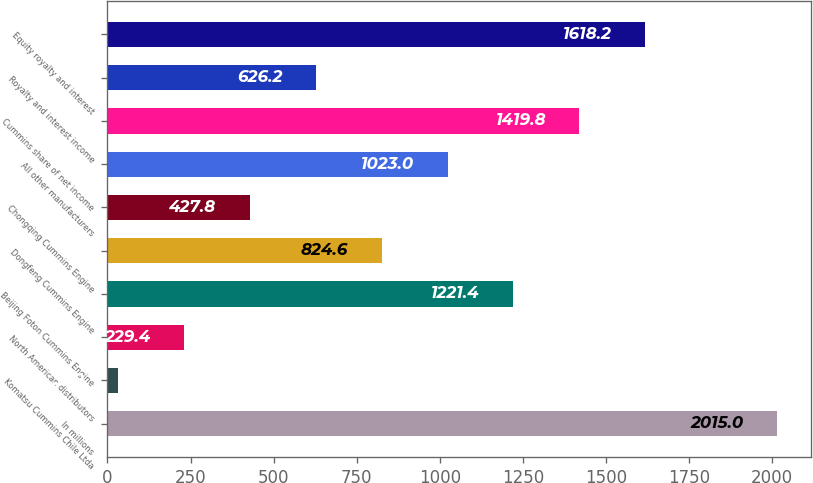Convert chart to OTSL. <chart><loc_0><loc_0><loc_500><loc_500><bar_chart><fcel>In millions<fcel>Komatsu Cummins Chile Ltda<fcel>North American distributors<fcel>Beijing Foton Cummins Engine<fcel>Dongfeng Cummins Engine<fcel>Chongqing Cummins Engine<fcel>All other manufacturers<fcel>Cummins share of net income<fcel>Royalty and interest income<fcel>Equity royalty and interest<nl><fcel>2015<fcel>31<fcel>229.4<fcel>1221.4<fcel>824.6<fcel>427.8<fcel>1023<fcel>1419.8<fcel>626.2<fcel>1618.2<nl></chart> 